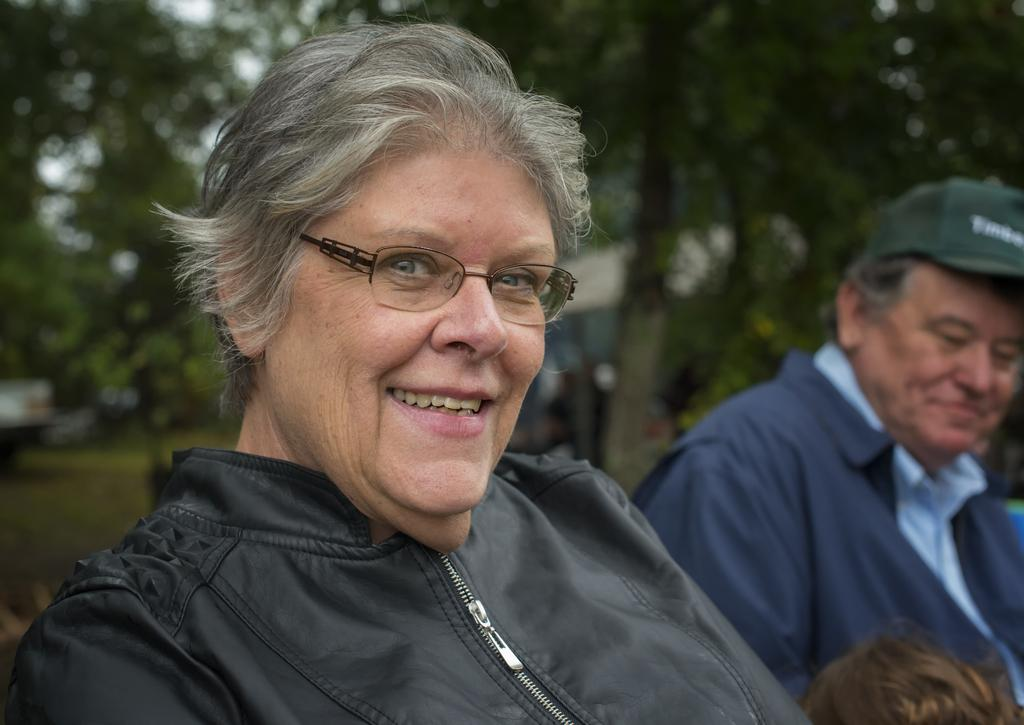How many people are sitting in the image? There are two people sitting in the image. What is the ground made of in the background of the image? There is grass on the ground in the background of the image. What type of vegetation can be seen in the background of the image? There are green trees visible in the background of the image. Can you see any squirrels wearing shoes in the image? There are no squirrels or shoes present in the image. 